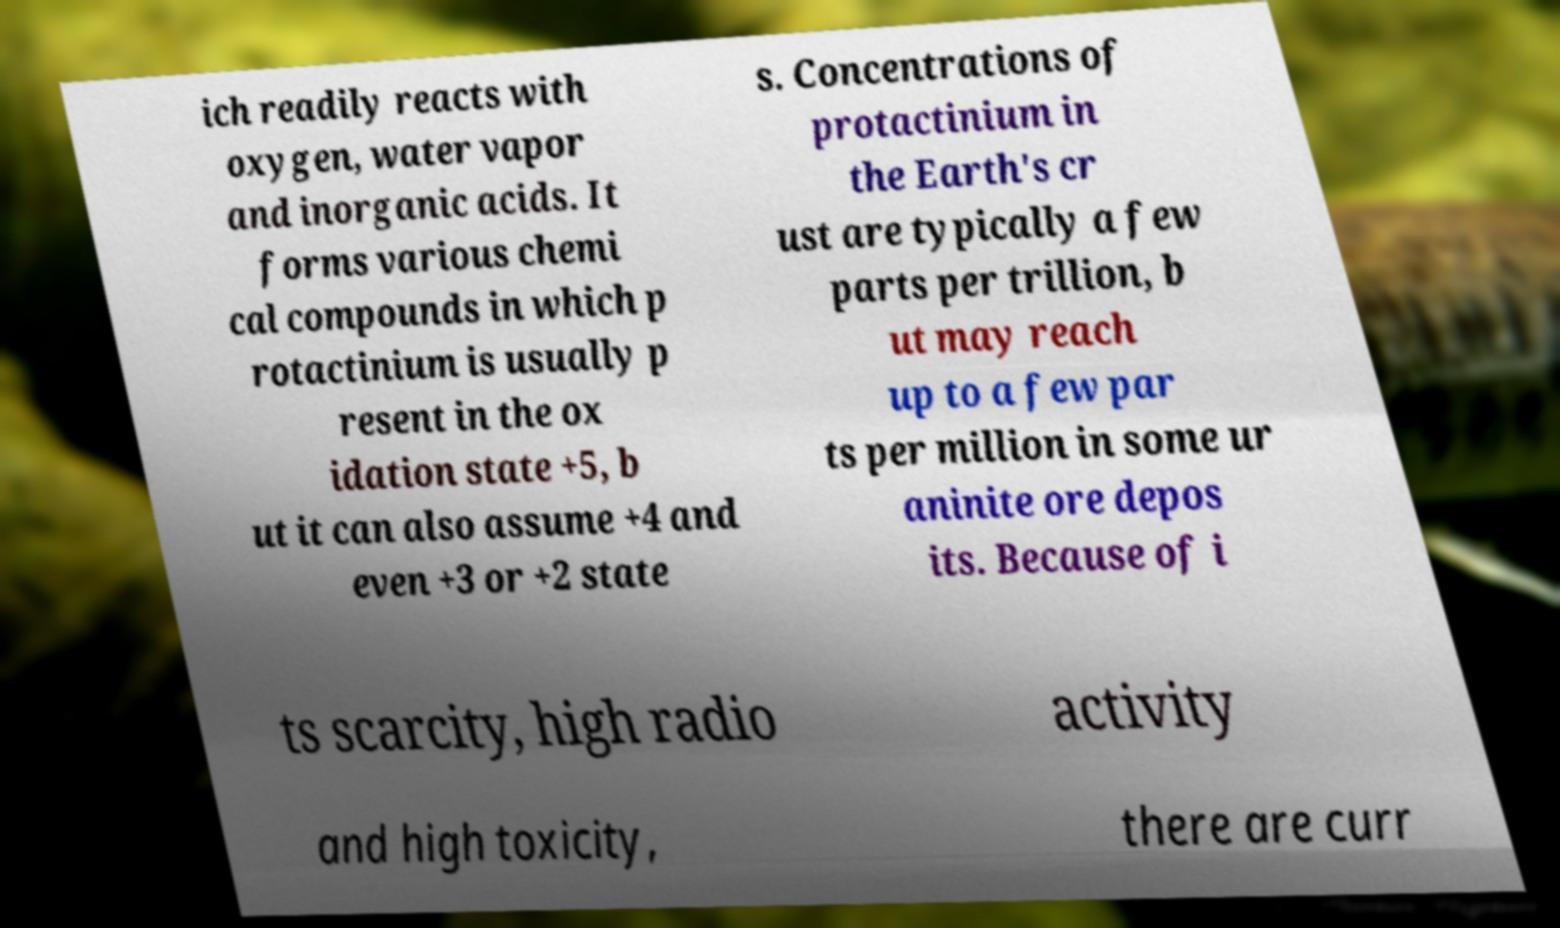For documentation purposes, I need the text within this image transcribed. Could you provide that? ich readily reacts with oxygen, water vapor and inorganic acids. It forms various chemi cal compounds in which p rotactinium is usually p resent in the ox idation state +5, b ut it can also assume +4 and even +3 or +2 state s. Concentrations of protactinium in the Earth's cr ust are typically a few parts per trillion, b ut may reach up to a few par ts per million in some ur aninite ore depos its. Because of i ts scarcity, high radio activity and high toxicity, there are curr 